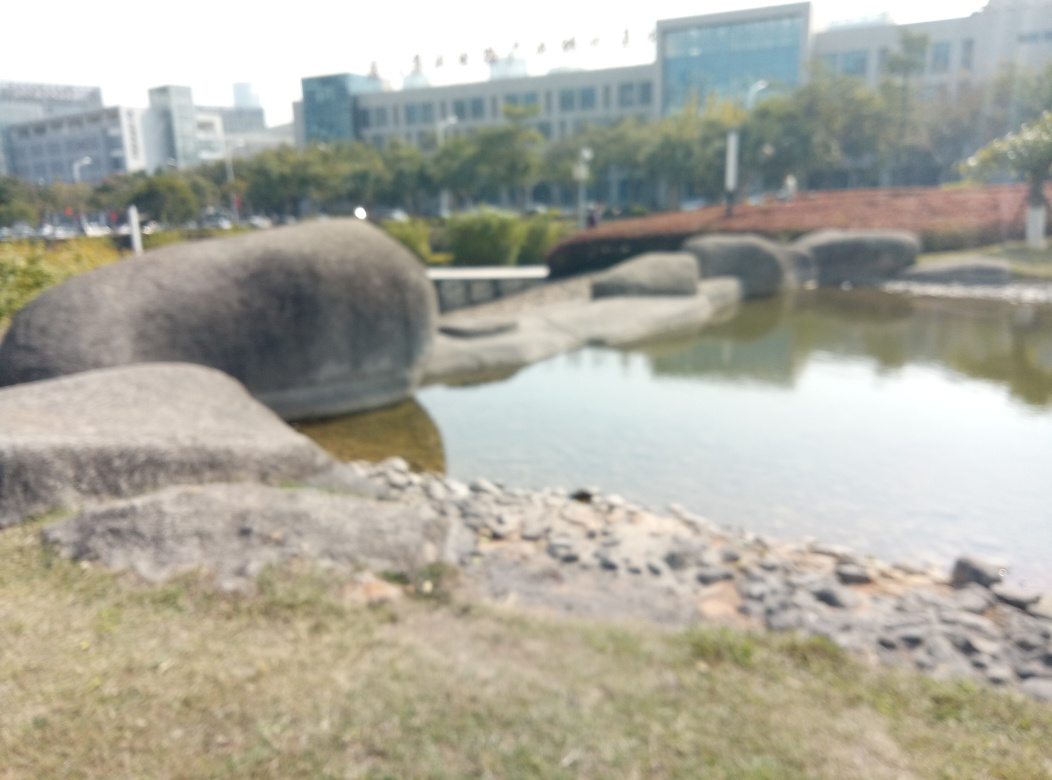Can you tell what the weather was like when this picture was taken? While it's not possible to ascertain precise weather conditions due to the lack of clarity in the image, there are no obvious signs of rain, such as droplets or splashes on surfaces. The overall brightness suggests it was likely a clear or partly cloudy day. 